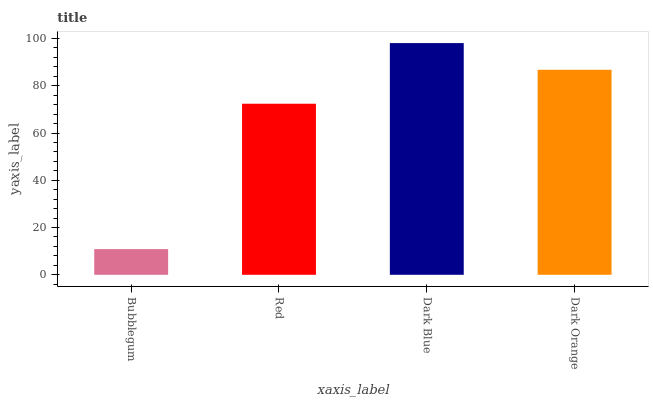Is Bubblegum the minimum?
Answer yes or no. Yes. Is Dark Blue the maximum?
Answer yes or no. Yes. Is Red the minimum?
Answer yes or no. No. Is Red the maximum?
Answer yes or no. No. Is Red greater than Bubblegum?
Answer yes or no. Yes. Is Bubblegum less than Red?
Answer yes or no. Yes. Is Bubblegum greater than Red?
Answer yes or no. No. Is Red less than Bubblegum?
Answer yes or no. No. Is Dark Orange the high median?
Answer yes or no. Yes. Is Red the low median?
Answer yes or no. Yes. Is Bubblegum the high median?
Answer yes or no. No. Is Bubblegum the low median?
Answer yes or no. No. 